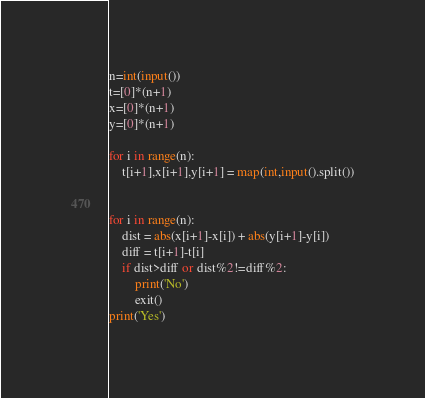Convert code to text. <code><loc_0><loc_0><loc_500><loc_500><_Python_>n=int(input())
t=[0]*(n+1)
x=[0]*(n+1)
y=[0]*(n+1)

for i in range(n):
    t[i+1],x[i+1],y[i+1] = map(int,input().split())

    
for i in range(n):
    dist = abs(x[i+1]-x[i]) + abs(y[i+1]-y[i])
    diff = t[i+1]-t[i]
    if dist>diff or dist%2!=diff%2:
        print('No')
        exit()
print('Yes')</code> 